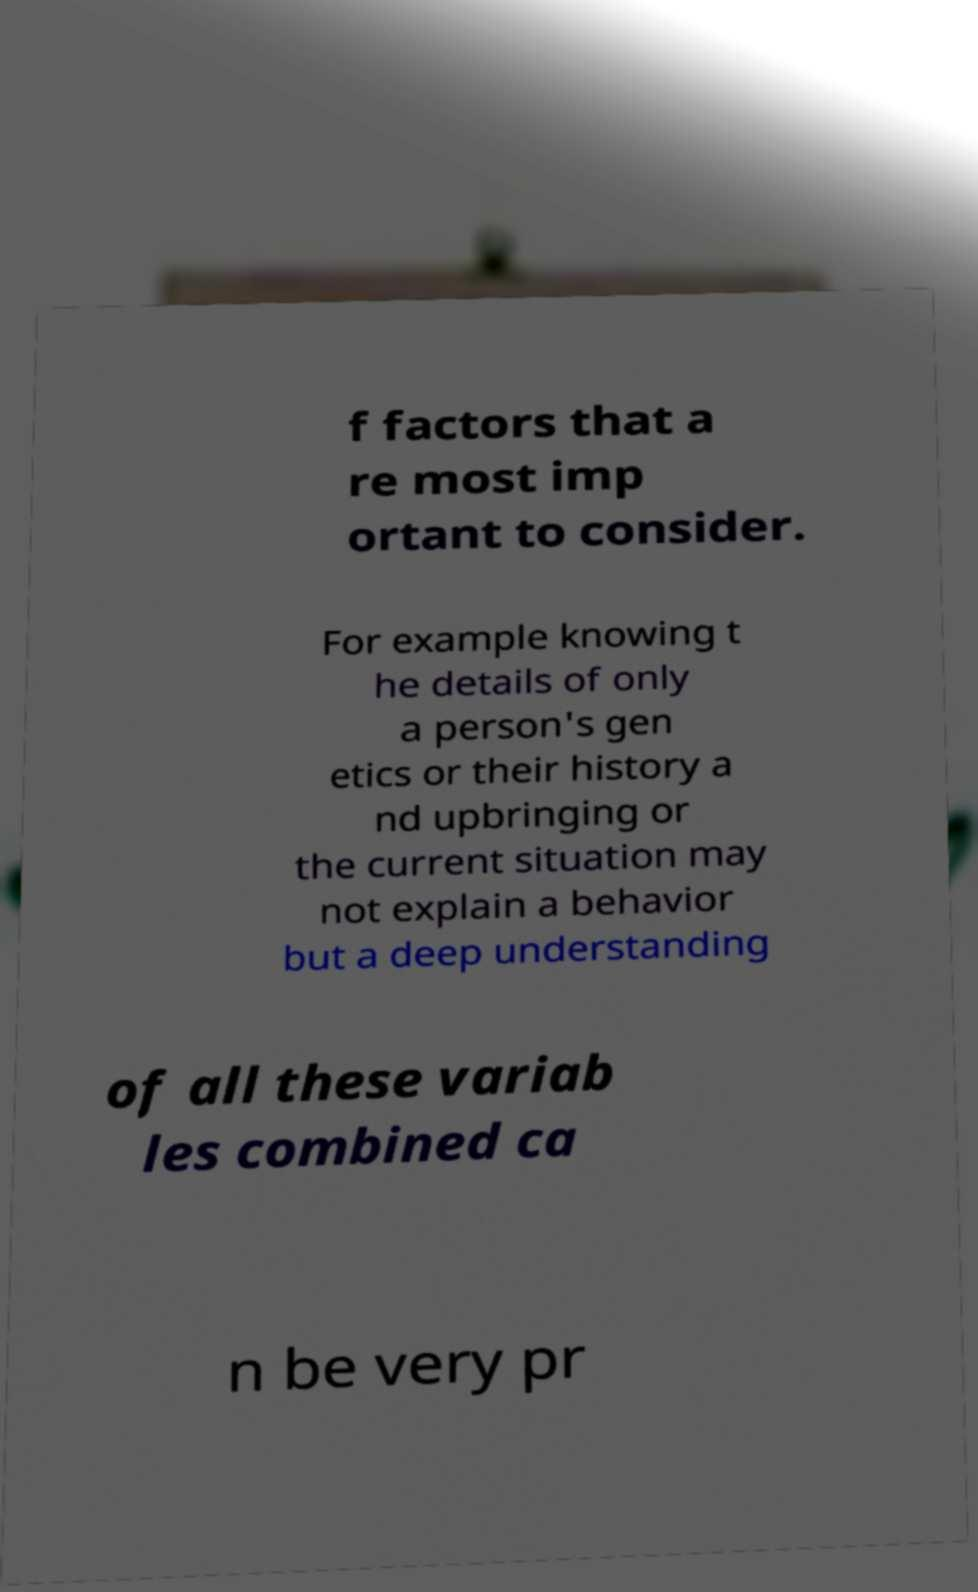For documentation purposes, I need the text within this image transcribed. Could you provide that? f factors that a re most imp ortant to consider. For example knowing t he details of only a person's gen etics or their history a nd upbringing or the current situation may not explain a behavior but a deep understanding of all these variab les combined ca n be very pr 